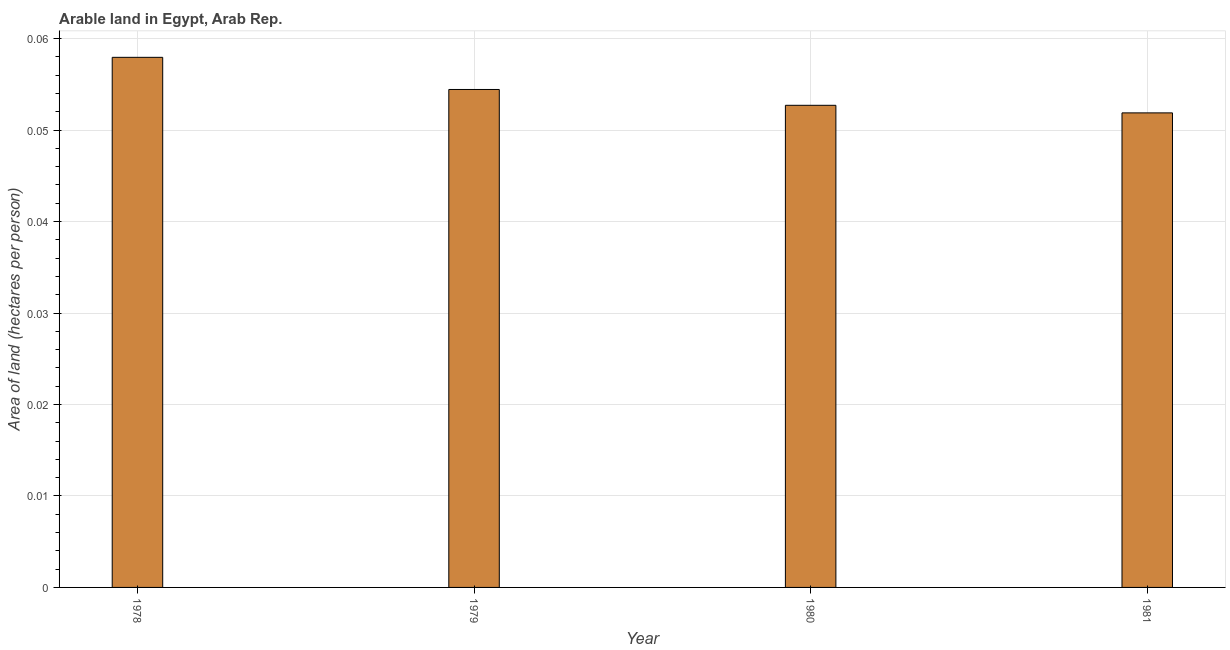Does the graph contain grids?
Your answer should be very brief. Yes. What is the title of the graph?
Keep it short and to the point. Arable land in Egypt, Arab Rep. What is the label or title of the Y-axis?
Make the answer very short. Area of land (hectares per person). What is the area of arable land in 1979?
Provide a short and direct response. 0.05. Across all years, what is the maximum area of arable land?
Keep it short and to the point. 0.06. Across all years, what is the minimum area of arable land?
Offer a very short reply. 0.05. In which year was the area of arable land maximum?
Your answer should be compact. 1978. In which year was the area of arable land minimum?
Your answer should be very brief. 1981. What is the sum of the area of arable land?
Provide a short and direct response. 0.22. What is the difference between the area of arable land in 1978 and 1980?
Your response must be concise. 0.01. What is the average area of arable land per year?
Your response must be concise. 0.05. What is the median area of arable land?
Provide a short and direct response. 0.05. Is the area of arable land in 1978 less than that in 1981?
Give a very brief answer. No. Is the difference between the area of arable land in 1978 and 1981 greater than the difference between any two years?
Keep it short and to the point. Yes. What is the difference between the highest and the second highest area of arable land?
Provide a short and direct response. 0. What is the difference between the highest and the lowest area of arable land?
Provide a succinct answer. 0.01. How many years are there in the graph?
Provide a short and direct response. 4. What is the difference between two consecutive major ticks on the Y-axis?
Ensure brevity in your answer.  0.01. Are the values on the major ticks of Y-axis written in scientific E-notation?
Offer a very short reply. No. What is the Area of land (hectares per person) in 1978?
Keep it short and to the point. 0.06. What is the Area of land (hectares per person) in 1979?
Make the answer very short. 0.05. What is the Area of land (hectares per person) in 1980?
Make the answer very short. 0.05. What is the Area of land (hectares per person) in 1981?
Keep it short and to the point. 0.05. What is the difference between the Area of land (hectares per person) in 1978 and 1979?
Provide a succinct answer. 0. What is the difference between the Area of land (hectares per person) in 1978 and 1980?
Give a very brief answer. 0.01. What is the difference between the Area of land (hectares per person) in 1978 and 1981?
Provide a succinct answer. 0.01. What is the difference between the Area of land (hectares per person) in 1979 and 1980?
Provide a short and direct response. 0. What is the difference between the Area of land (hectares per person) in 1979 and 1981?
Provide a short and direct response. 0. What is the difference between the Area of land (hectares per person) in 1980 and 1981?
Offer a very short reply. 0. What is the ratio of the Area of land (hectares per person) in 1978 to that in 1979?
Ensure brevity in your answer.  1.06. What is the ratio of the Area of land (hectares per person) in 1978 to that in 1981?
Make the answer very short. 1.12. What is the ratio of the Area of land (hectares per person) in 1979 to that in 1980?
Make the answer very short. 1.03. What is the ratio of the Area of land (hectares per person) in 1979 to that in 1981?
Give a very brief answer. 1.05. 